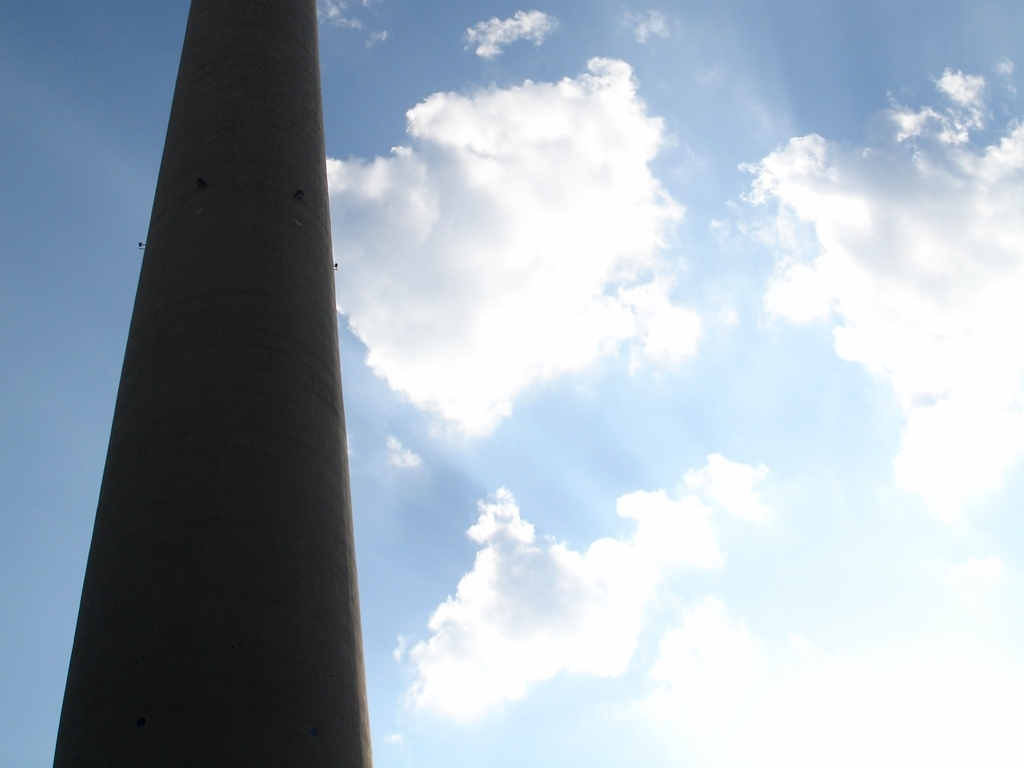What type of structure is shown in the image, and what might be its purpose? The image features a tall, cylindrical structure reaching into the sky, which resembles a chimney or industrial tower. These structures are typically used for ventilation or as exhausts to release gases at a height where they can disperse safely into the atmosphere. 